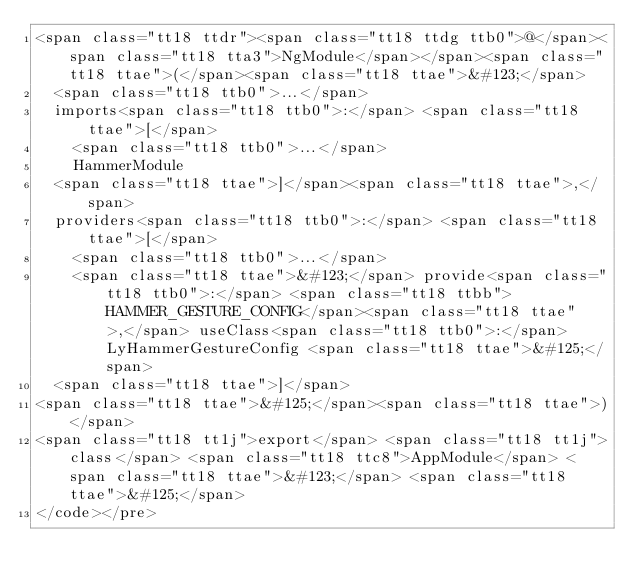Convert code to text. <code><loc_0><loc_0><loc_500><loc_500><_HTML_><span class="tt18 ttdr"><span class="tt18 ttdg ttb0">@</span><span class="tt18 tta3">NgModule</span></span><span class="tt18 ttae">(</span><span class="tt18 ttae">&#123;</span>
  <span class="tt18 ttb0">...</span>
  imports<span class="tt18 ttb0">:</span> <span class="tt18 ttae">[</span>
    <span class="tt18 ttb0">...</span>
    HammerModule
  <span class="tt18 ttae">]</span><span class="tt18 ttae">,</span>
  providers<span class="tt18 ttb0">:</span> <span class="tt18 ttae">[</span>
    <span class="tt18 ttb0">...</span>
    <span class="tt18 ttae">&#123;</span> provide<span class="tt18 ttb0">:</span> <span class="tt18 ttbb">HAMMER_GESTURE_CONFIG</span><span class="tt18 ttae">,</span> useClass<span class="tt18 ttb0">:</span> LyHammerGestureConfig <span class="tt18 ttae">&#125;</span>
  <span class="tt18 ttae">]</span>
<span class="tt18 ttae">&#125;</span><span class="tt18 ttae">)</span>
<span class="tt18 tt1j">export</span> <span class="tt18 tt1j">class</span> <span class="tt18 ttc8">AppModule</span> <span class="tt18 ttae">&#123;</span> <span class="tt18 ttae">&#125;</span>
</code></pre></code> 